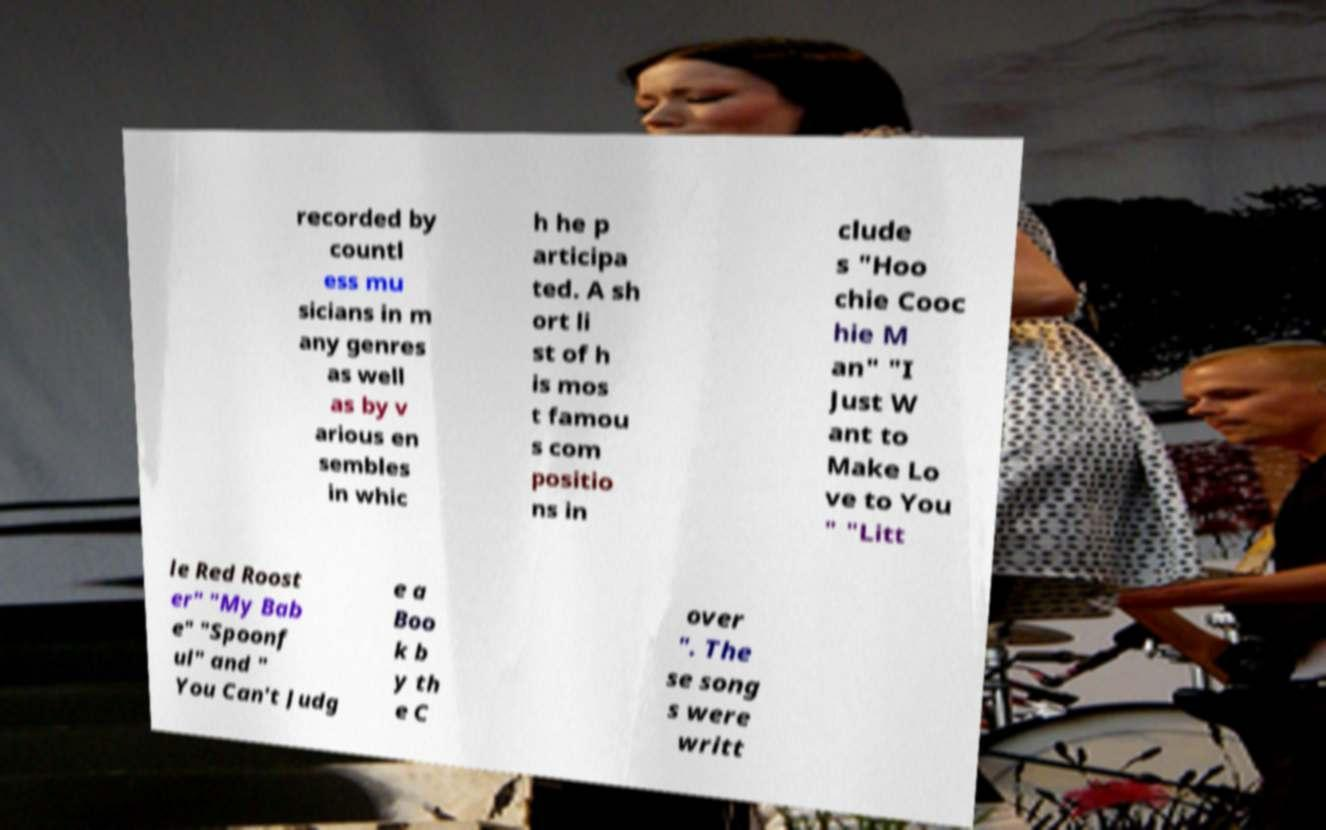For documentation purposes, I need the text within this image transcribed. Could you provide that? recorded by countl ess mu sicians in m any genres as well as by v arious en sembles in whic h he p articipa ted. A sh ort li st of h is mos t famou s com positio ns in clude s "Hoo chie Cooc hie M an" "I Just W ant to Make Lo ve to You " "Litt le Red Roost er" "My Bab e" "Spoonf ul" and " You Can't Judg e a Boo k b y th e C over ". The se song s were writt 